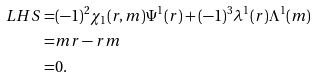<formula> <loc_0><loc_0><loc_500><loc_500>L H S = & ( - 1 ) ^ { 2 } \chi _ { 1 } ( r , m ) \Psi ^ { 1 } ( r ) + ( - 1 ) ^ { 3 } \lambda ^ { 1 } ( r ) \Lambda ^ { 1 } ( m ) \\ = & m r - r m \\ = & 0 .</formula> 